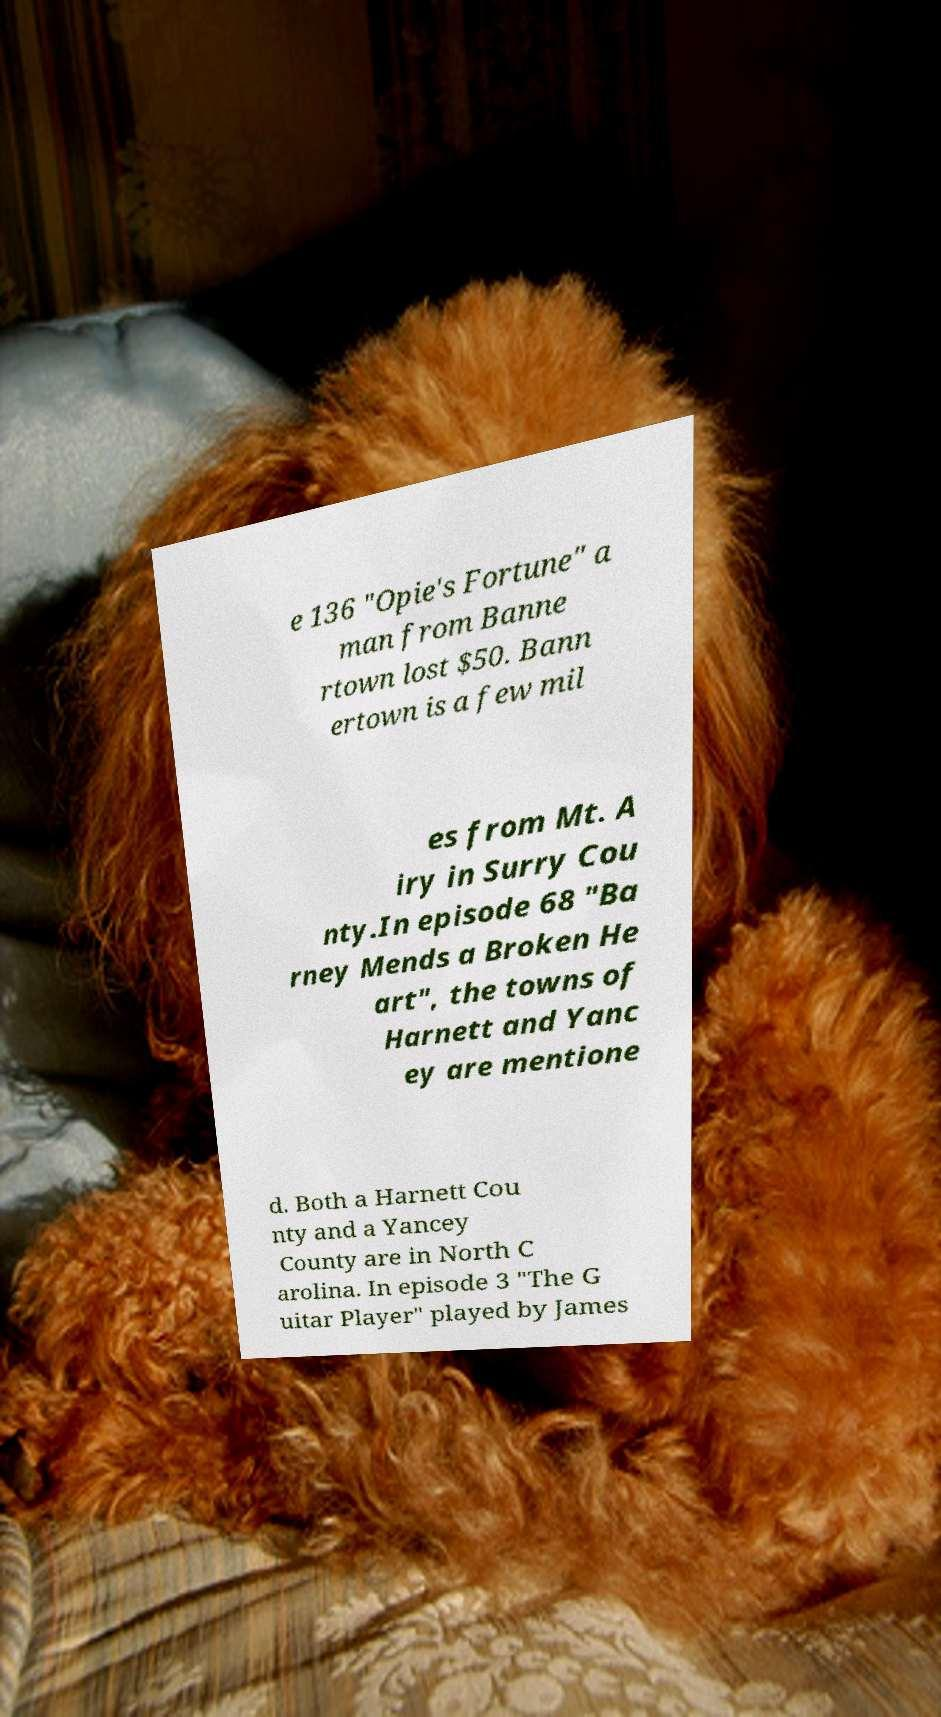Please read and relay the text visible in this image. What does it say? e 136 "Opie's Fortune" a man from Banne rtown lost $50. Bann ertown is a few mil es from Mt. A iry in Surry Cou nty.In episode 68 "Ba rney Mends a Broken He art", the towns of Harnett and Yanc ey are mentione d. Both a Harnett Cou nty and a Yancey County are in North C arolina. In episode 3 "The G uitar Player" played by James 